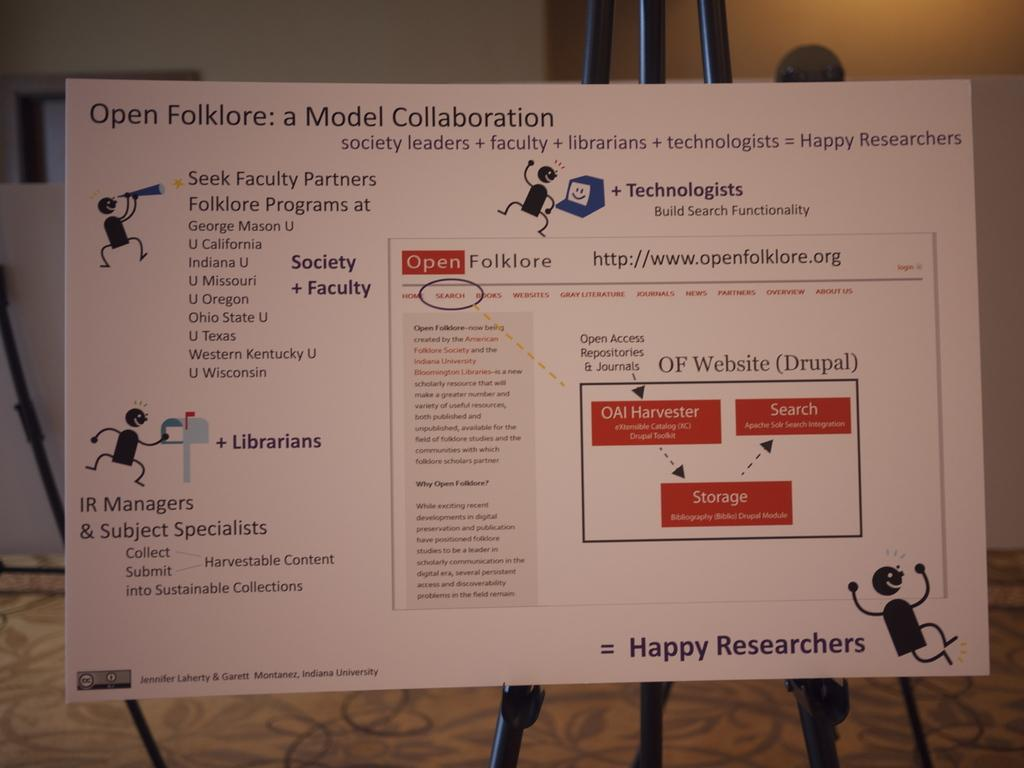Provide a one-sentence caption for the provided image. A poster explains concepts and details behind the Open Folklore collaboration model. 